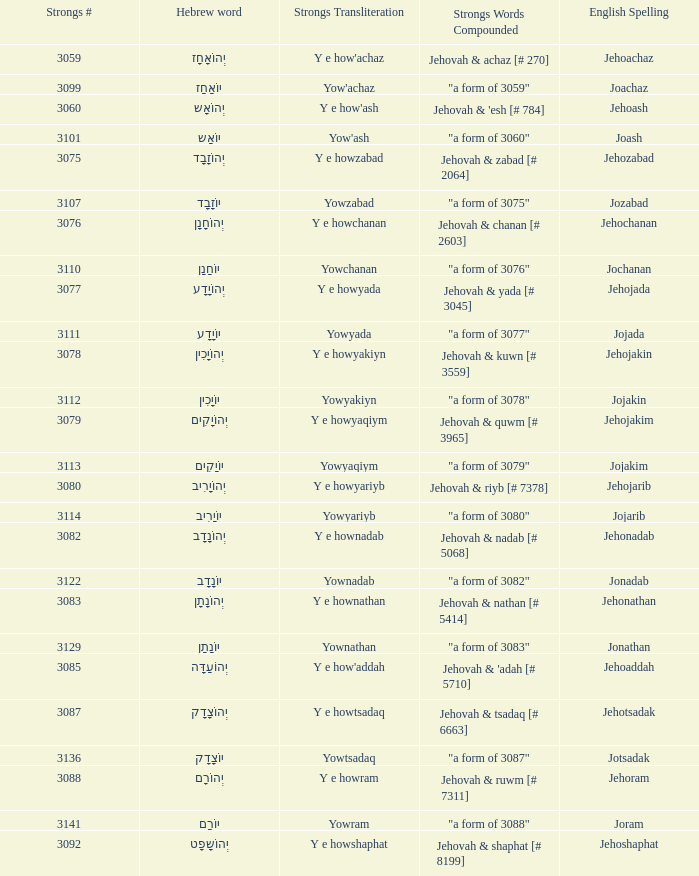What is the strong words compounded when the strongs transliteration is yowyariyb? "a form of 3080". 